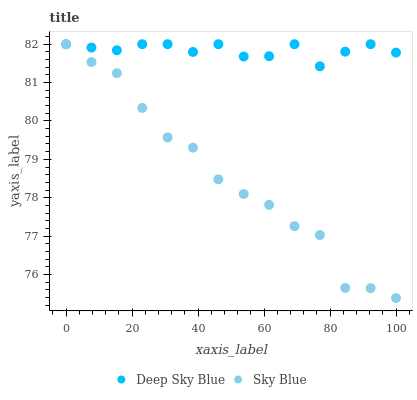Does Sky Blue have the minimum area under the curve?
Answer yes or no. Yes. Does Deep Sky Blue have the maximum area under the curve?
Answer yes or no. Yes. Does Deep Sky Blue have the minimum area under the curve?
Answer yes or no. No. Is Deep Sky Blue the smoothest?
Answer yes or no. Yes. Is Sky Blue the roughest?
Answer yes or no. Yes. Is Deep Sky Blue the roughest?
Answer yes or no. No. Does Sky Blue have the lowest value?
Answer yes or no. Yes. Does Deep Sky Blue have the lowest value?
Answer yes or no. No. Does Deep Sky Blue have the highest value?
Answer yes or no. Yes. Does Deep Sky Blue intersect Sky Blue?
Answer yes or no. Yes. Is Deep Sky Blue less than Sky Blue?
Answer yes or no. No. Is Deep Sky Blue greater than Sky Blue?
Answer yes or no. No. 